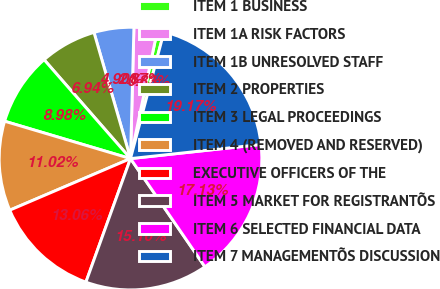Convert chart. <chart><loc_0><loc_0><loc_500><loc_500><pie_chart><fcel>ITEM 1 BUSINESS<fcel>ITEM 1A RISK FACTORS<fcel>ITEM 1B UNRESOLVED STAFF<fcel>ITEM 2 PROPERTIES<fcel>ITEM 3 LEGAL PROCEEDINGS<fcel>ITEM 4 (REMOVED AND RESERVED)<fcel>EXECUTIVE OFFICERS OF THE<fcel>ITEM 5 MARKET FOR REGISTRANTÕS<fcel>ITEM 6 SELECTED FINANCIAL DATA<fcel>ITEM 7 MANAGEMENTÕS DISCUSSION<nl><fcel>0.83%<fcel>2.87%<fcel>4.9%<fcel>6.94%<fcel>8.98%<fcel>11.02%<fcel>13.06%<fcel>15.1%<fcel>17.13%<fcel>19.17%<nl></chart> 